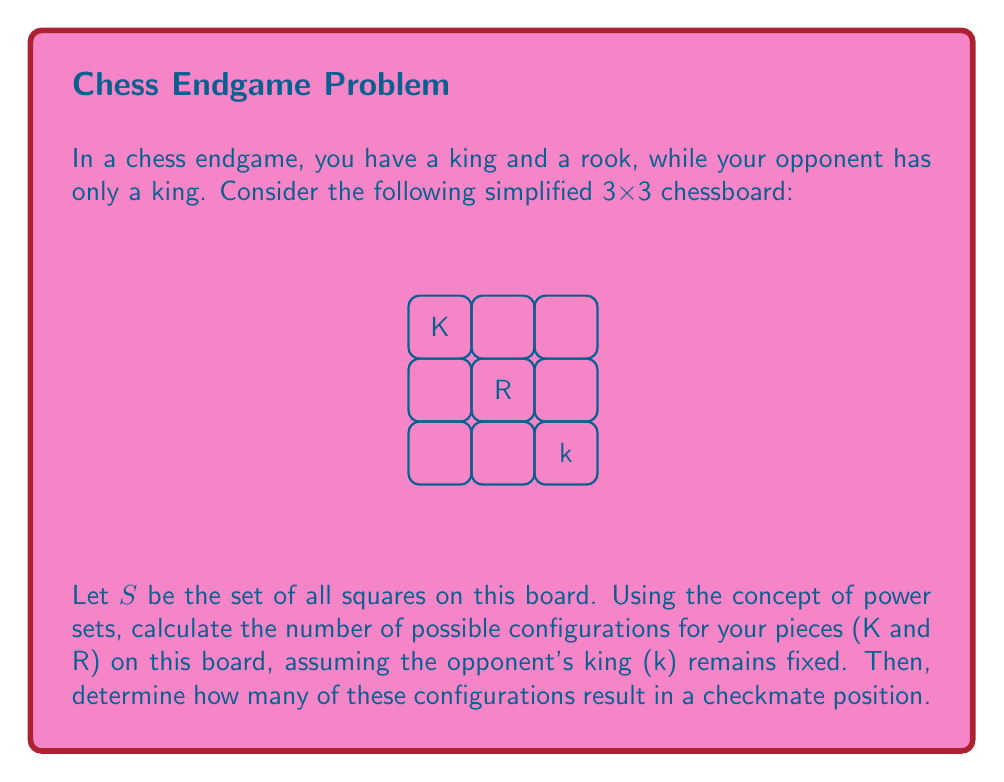Can you answer this question? Let's approach this step-by-step:

1) First, we need to understand what the power set is. The power set of a set $S$ is the set of all subsets of $S$, including the empty set and $S$ itself. It is denoted as $P(S)$.

2) In this case, we have a 3x3 board, so $|S| = 9$ (there are 9 squares).

3) We need to place two pieces (K and R) on the board. This is equivalent to choosing a 2-element subset from $S$.

4) The number of k-element subsets of an n-element set is given by the combination formula:

   $$\binom{n}{k} = \frac{n!}{k!(n-k)!}$$

5) In our case, $n = 9$ (total squares) and $k = 2$ (our pieces). So the number of possible configurations is:

   $$\binom{9}{2} = \frac{9!}{2!(9-2)!} = \frac{9 * 8}{2} = 36$$

6) Now, for the checkmate positions. A checkmate occurs when:
   - The opponent's king is in check
   - The opponent's king has no legal moves

7) Given the fixed position of the opponent's king, there are 3 checkmate configurations:
   - King on (0,2) and Rook on (1,0)
   - King on (0,1) and Rook on (2,0)
   - King on (1,2) and Rook on (2,1)

Therefore, out of 36 possible configurations, 3 result in checkmate.
Answer: 36 possible configurations; 3 checkmate positions 